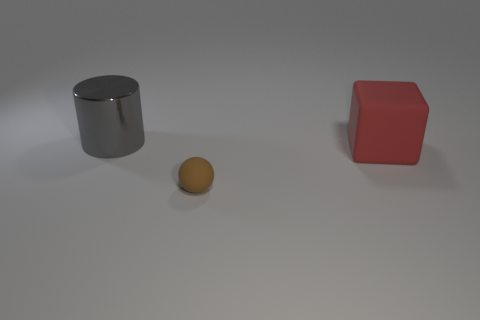Add 1 big cylinders. How many objects exist? 4 Subtract all cubes. How many objects are left? 2 Add 2 large purple rubber blocks. How many large purple rubber blocks exist? 2 Subtract 1 gray cylinders. How many objects are left? 2 Subtract all spheres. Subtract all large gray objects. How many objects are left? 1 Add 1 big gray metal things. How many big gray metal things are left? 2 